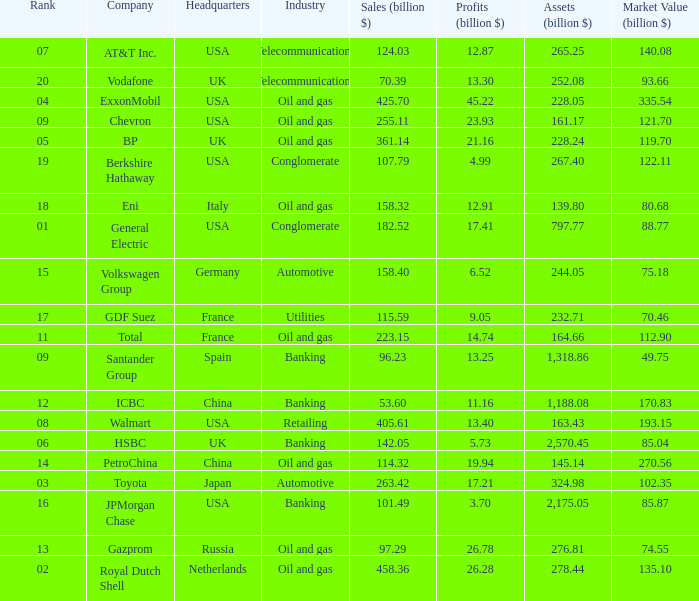Name the highest Profits (billion $) which has a Company of walmart? 13.4. 